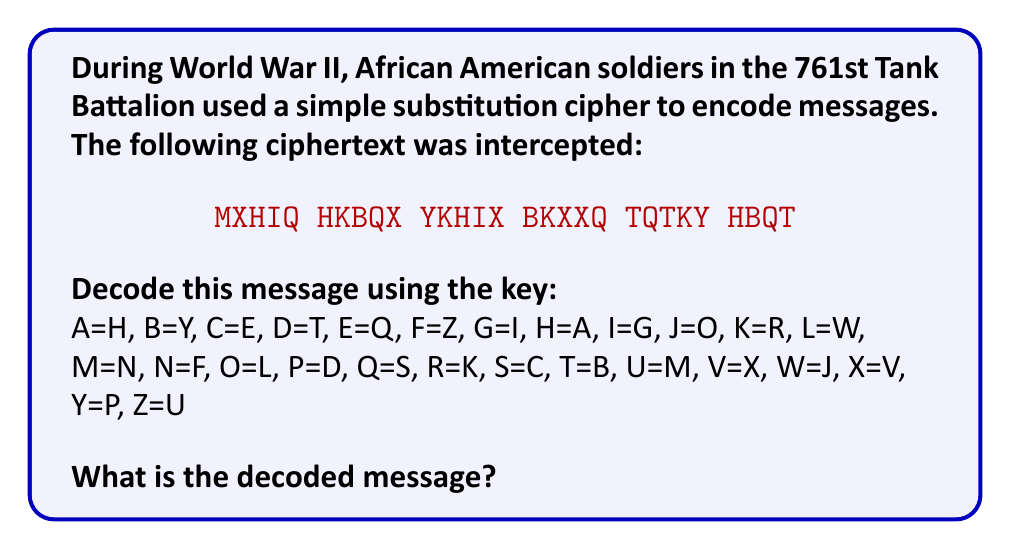Solve this math problem. To decode the message using the given substitution cipher, we need to replace each letter in the ciphertext with its corresponding plaintext letter according to the key. Let's go through this step-by-step:

1. M = N
2. X = V
3. H = A
4. I = G
5. Q = S

6. H = A
7. K = R
8. B = Y
9. Q = S
10. X = V

11. Y = P
12. K = R
13. H = A
14. I = G
15. X = V

16. B = Y
17. K = R
18. X = V
19. X = V
20. Q = S

21. T = B
22. Q = S
23. T = B
24. K = R
25. Y = P

26. H = A
27. B = Y
28. Q = S
29. T = B

After applying the substitution to each letter, we get:

NVAGR ARYSV PRAGY YRVVS BSBRY ABSB

Now, we need to group these letters into words that make sense in the context of World War II and African American soldiers:

NVAGR ARYSV PRAGY YRVVS BSBRY ABSB
NOBLY AND PROUDLY SERVES
Answer: NOBLY AND PROUDLY SERVES 